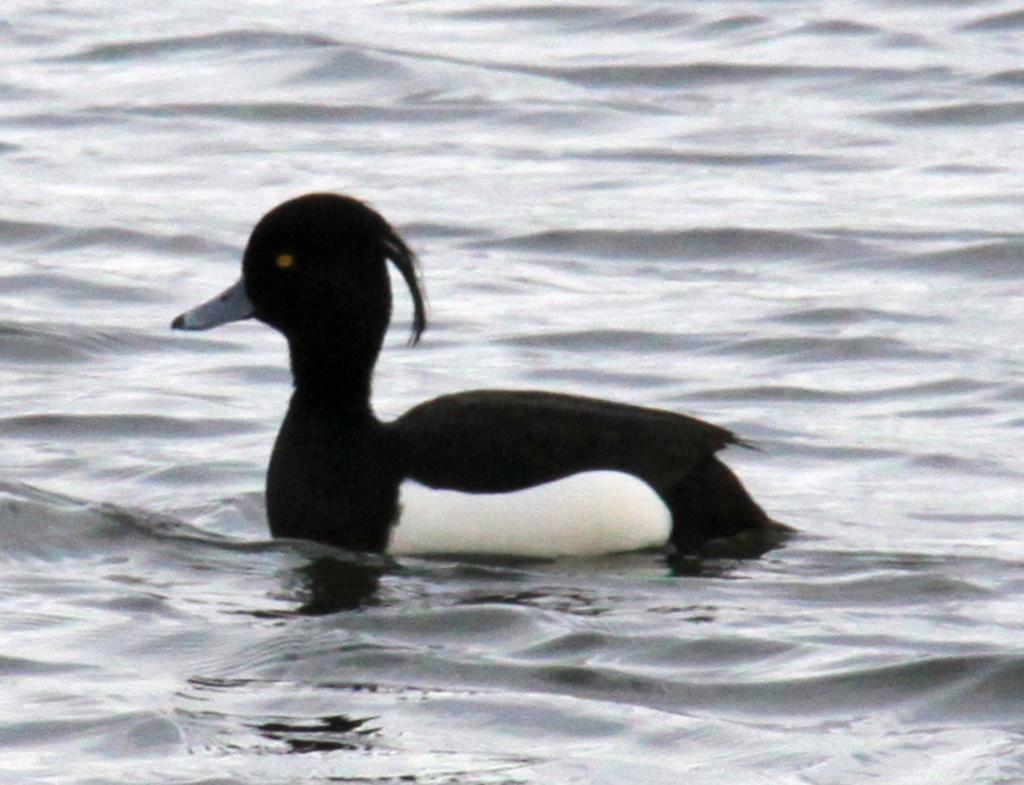What type of bird is in the image? There is a Hooded merganser in the image. What colors are present in the Hooded merganser? The Hooded merganser is in black and white color. Where is the Hooded merganser located in the image? The Hooded merganser is on the water. What type of car is being used to prepare the meal in the image? There is no car or meal present in the image; it features a Hooded merganser on the water. 